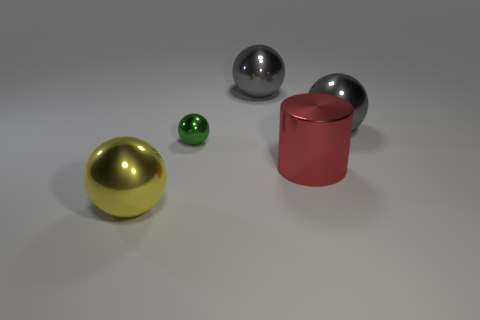Subtract 1 balls. How many balls are left? 3 Add 4 large gray spheres. How many objects exist? 9 Subtract all spheres. How many objects are left? 1 Add 2 large gray shiny things. How many large gray shiny things exist? 4 Subtract 1 yellow balls. How many objects are left? 4 Subtract all big red cubes. Subtract all big metallic spheres. How many objects are left? 2 Add 1 green spheres. How many green spheres are left? 2 